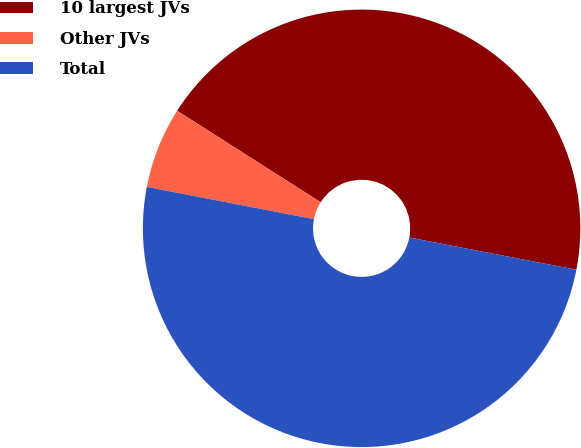Convert chart to OTSL. <chart><loc_0><loc_0><loc_500><loc_500><pie_chart><fcel>10 largest JVs<fcel>Other JVs<fcel>Total<nl><fcel>44.0%<fcel>6.0%<fcel>50.0%<nl></chart> 